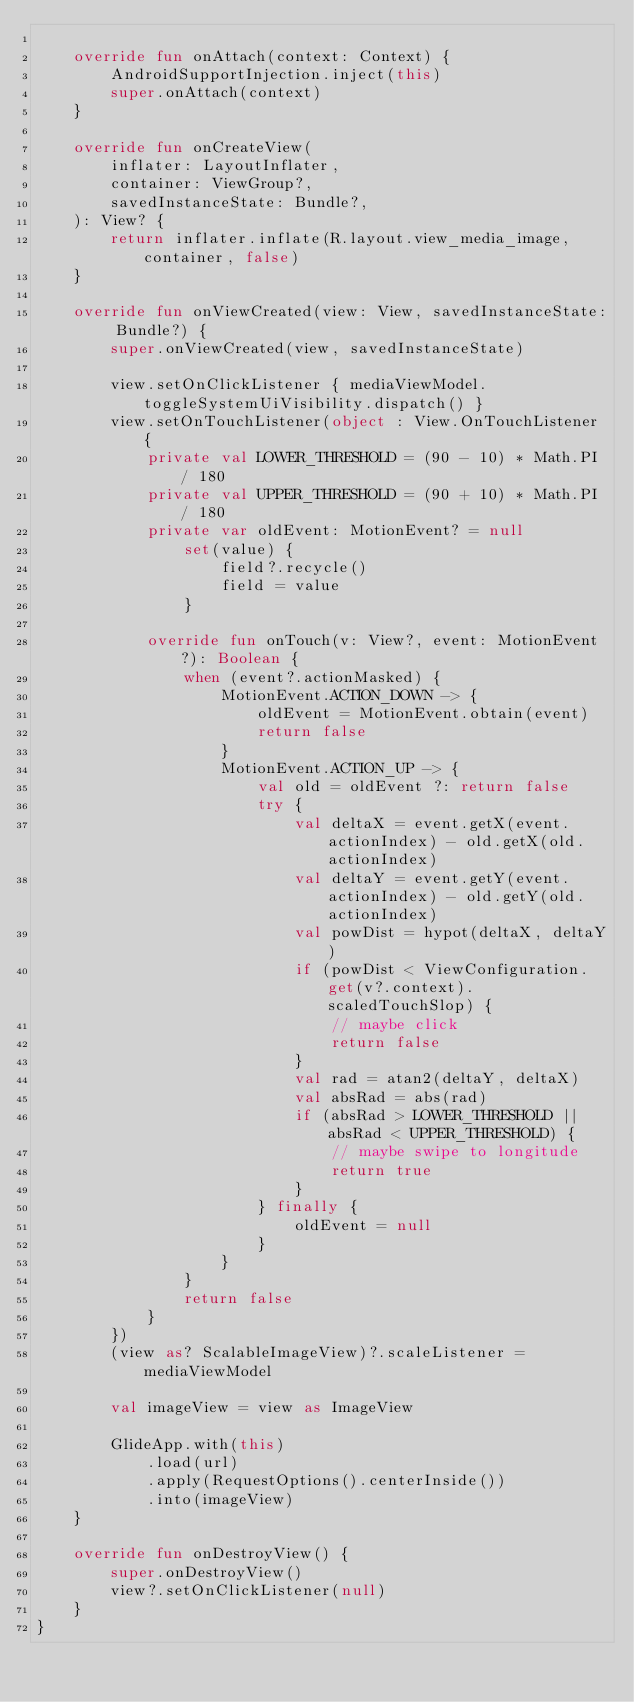<code> <loc_0><loc_0><loc_500><loc_500><_Kotlin_>
    override fun onAttach(context: Context) {
        AndroidSupportInjection.inject(this)
        super.onAttach(context)
    }

    override fun onCreateView(
        inflater: LayoutInflater,
        container: ViewGroup?,
        savedInstanceState: Bundle?,
    ): View? {
        return inflater.inflate(R.layout.view_media_image, container, false)
    }

    override fun onViewCreated(view: View, savedInstanceState: Bundle?) {
        super.onViewCreated(view, savedInstanceState)

        view.setOnClickListener { mediaViewModel.toggleSystemUiVisibility.dispatch() }
        view.setOnTouchListener(object : View.OnTouchListener {
            private val LOWER_THRESHOLD = (90 - 10) * Math.PI / 180
            private val UPPER_THRESHOLD = (90 + 10) * Math.PI / 180
            private var oldEvent: MotionEvent? = null
                set(value) {
                    field?.recycle()
                    field = value
                }

            override fun onTouch(v: View?, event: MotionEvent?): Boolean {
                when (event?.actionMasked) {
                    MotionEvent.ACTION_DOWN -> {
                        oldEvent = MotionEvent.obtain(event)
                        return false
                    }
                    MotionEvent.ACTION_UP -> {
                        val old = oldEvent ?: return false
                        try {
                            val deltaX = event.getX(event.actionIndex) - old.getX(old.actionIndex)
                            val deltaY = event.getY(event.actionIndex) - old.getY(old.actionIndex)
                            val powDist = hypot(deltaX, deltaY)
                            if (powDist < ViewConfiguration.get(v?.context).scaledTouchSlop) {
                                // maybe click
                                return false
                            }
                            val rad = atan2(deltaY, deltaX)
                            val absRad = abs(rad)
                            if (absRad > LOWER_THRESHOLD || absRad < UPPER_THRESHOLD) {
                                // maybe swipe to longitude
                                return true
                            }
                        } finally {
                            oldEvent = null
                        }
                    }
                }
                return false
            }
        })
        (view as? ScalableImageView)?.scaleListener = mediaViewModel

        val imageView = view as ImageView

        GlideApp.with(this)
            .load(url)
            .apply(RequestOptions().centerInside())
            .into(imageView)
    }

    override fun onDestroyView() {
        super.onDestroyView()
        view?.setOnClickListener(null)
    }
}
</code> 